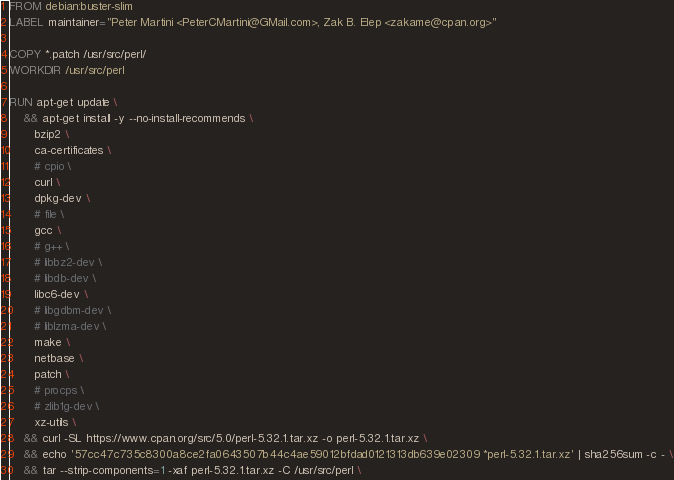<code> <loc_0><loc_0><loc_500><loc_500><_Dockerfile_>FROM debian:buster-slim
LABEL maintainer="Peter Martini <PeterCMartini@GMail.com>, Zak B. Elep <zakame@cpan.org>"

COPY *.patch /usr/src/perl/
WORKDIR /usr/src/perl

RUN apt-get update \
    && apt-get install -y --no-install-recommends \
       bzip2 \
       ca-certificates \
       # cpio \
       curl \
       dpkg-dev \
       # file \
       gcc \
       # g++ \
       # libbz2-dev \
       # libdb-dev \
       libc6-dev \
       # libgdbm-dev \
       # liblzma-dev \
       make \
       netbase \
       patch \
       # procps \
       # zlib1g-dev \
       xz-utils \
    && curl -SL https://www.cpan.org/src/5.0/perl-5.32.1.tar.xz -o perl-5.32.1.tar.xz \
    && echo '57cc47c735c8300a8ce2fa0643507b44c4ae59012bfdad0121313db639e02309 *perl-5.32.1.tar.xz' | sha256sum -c - \
    && tar --strip-components=1 -xaf perl-5.32.1.tar.xz -C /usr/src/perl \</code> 